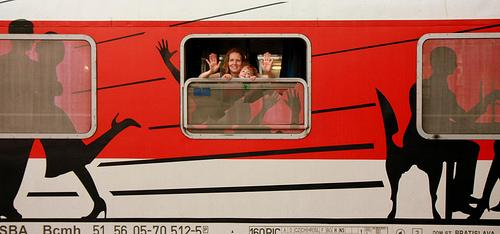What is the color scheme of the train's exterior artwork? Red and white surface with black lines and various images. Analyze the interaction between the woman and the child in the train's window. The woman and the child seem to be enjoying their time together, smiling, and waving at something or someone outside the train window. Identify the artwork seen on the side of the train. There's a silhouette of a man and woman dancing, a painting of high heel shoe, and a scene of a man sitting at a table with someone. How many windows are there in a row and are they open or closed? There are three windows in a row, with one window being open and two windows being closed. Please count the number of hands visible in the image, including those in the artwork. There are a total of 8 hands visible in the image. Describe the two main characters in the window of the train and their actions. A woman and a little girl are looking out the window, holding onto the window ledge, smiling, and waving their hands. What is the main activity happening inside the train's window? A woman and a child are looking out the window, with the child holding onto the window and both of them waving. Identify the emotion or sentiment conveyed by the people looking out of the train's window. The woman and little girl are expressing happiness and excitement while looking out of the window. Is there an image of a bicycle drawn on the side of the train car? No, it's not mentioned in the image. Is the woman dancing on the side of the train wearing a red dress? There is no mention of the color of the woman's dress in the information, so suggesting a specific color is misleading. 